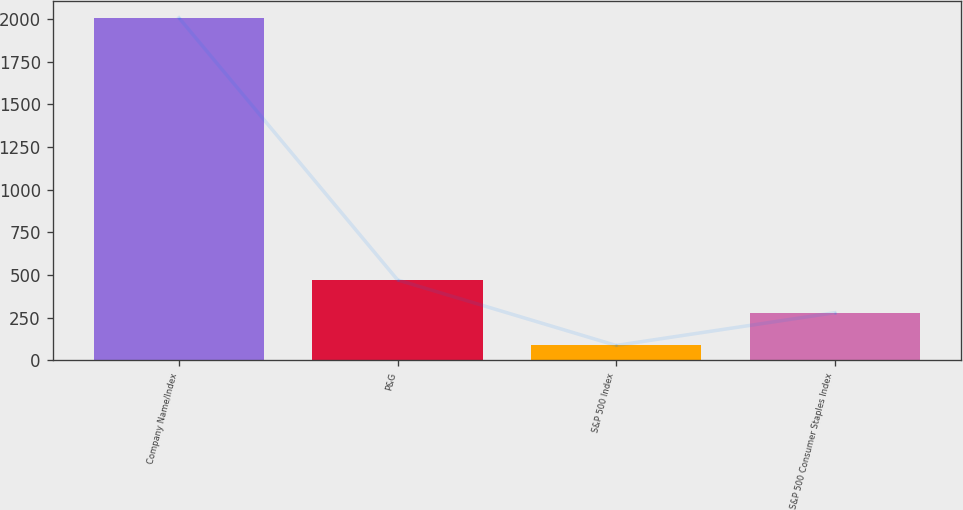Convert chart. <chart><loc_0><loc_0><loc_500><loc_500><bar_chart><fcel>Company Name/Index<fcel>P&G<fcel>S&P 500 Index<fcel>S&P 500 Consumer Staples Index<nl><fcel>2008<fcel>471.2<fcel>87<fcel>279.1<nl></chart> 